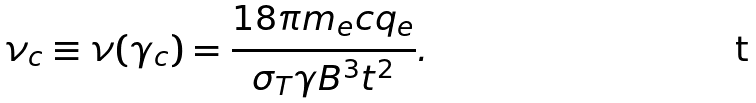<formula> <loc_0><loc_0><loc_500><loc_500>\nu _ { c } \equiv \nu ( \gamma _ { c } ) = \frac { 1 8 \pi m _ { e } c q _ { e } } { \sigma _ { T } \gamma B ^ { 3 } t ^ { 2 } } .</formula> 